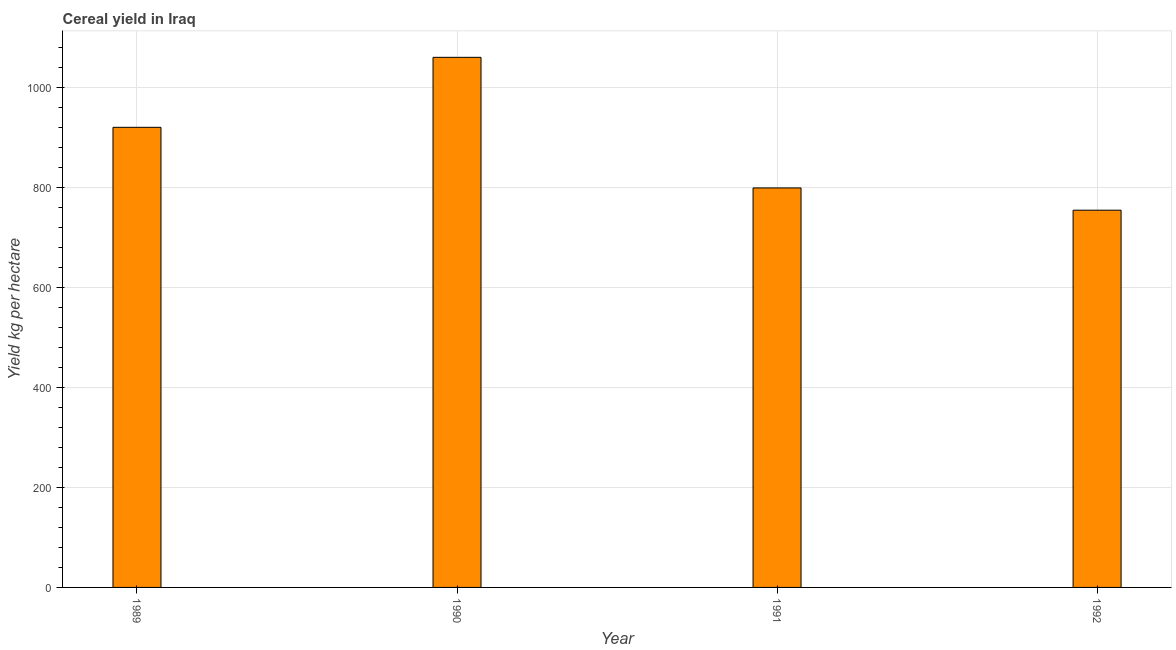Does the graph contain any zero values?
Your response must be concise. No. What is the title of the graph?
Ensure brevity in your answer.  Cereal yield in Iraq. What is the label or title of the X-axis?
Give a very brief answer. Year. What is the label or title of the Y-axis?
Make the answer very short. Yield kg per hectare. What is the cereal yield in 1992?
Keep it short and to the point. 755. Across all years, what is the maximum cereal yield?
Your response must be concise. 1060.96. Across all years, what is the minimum cereal yield?
Provide a succinct answer. 755. In which year was the cereal yield maximum?
Provide a short and direct response. 1990. What is the sum of the cereal yield?
Give a very brief answer. 3536.42. What is the difference between the cereal yield in 1990 and 1992?
Make the answer very short. 305.96. What is the average cereal yield per year?
Ensure brevity in your answer.  884.11. What is the median cereal yield?
Make the answer very short. 860.23. In how many years, is the cereal yield greater than 440 kg per hectare?
Offer a terse response. 4. What is the ratio of the cereal yield in 1991 to that in 1992?
Offer a very short reply. 1.06. Is the difference between the cereal yield in 1990 and 1992 greater than the difference between any two years?
Your answer should be compact. Yes. What is the difference between the highest and the second highest cereal yield?
Offer a terse response. 140.07. What is the difference between the highest and the lowest cereal yield?
Offer a very short reply. 305.96. In how many years, is the cereal yield greater than the average cereal yield taken over all years?
Offer a very short reply. 2. Are all the bars in the graph horizontal?
Your response must be concise. No. How many years are there in the graph?
Provide a short and direct response. 4. What is the difference between two consecutive major ticks on the Y-axis?
Ensure brevity in your answer.  200. What is the Yield kg per hectare in 1989?
Your answer should be compact. 920.89. What is the Yield kg per hectare in 1990?
Your response must be concise. 1060.96. What is the Yield kg per hectare in 1991?
Your response must be concise. 799.58. What is the Yield kg per hectare of 1992?
Offer a very short reply. 755. What is the difference between the Yield kg per hectare in 1989 and 1990?
Your answer should be compact. -140.07. What is the difference between the Yield kg per hectare in 1989 and 1991?
Provide a short and direct response. 121.31. What is the difference between the Yield kg per hectare in 1989 and 1992?
Give a very brief answer. 165.89. What is the difference between the Yield kg per hectare in 1990 and 1991?
Your answer should be very brief. 261.38. What is the difference between the Yield kg per hectare in 1990 and 1992?
Your answer should be compact. 305.96. What is the difference between the Yield kg per hectare in 1991 and 1992?
Your answer should be compact. 44.58. What is the ratio of the Yield kg per hectare in 1989 to that in 1990?
Make the answer very short. 0.87. What is the ratio of the Yield kg per hectare in 1989 to that in 1991?
Ensure brevity in your answer.  1.15. What is the ratio of the Yield kg per hectare in 1989 to that in 1992?
Your response must be concise. 1.22. What is the ratio of the Yield kg per hectare in 1990 to that in 1991?
Offer a very short reply. 1.33. What is the ratio of the Yield kg per hectare in 1990 to that in 1992?
Provide a short and direct response. 1.41. What is the ratio of the Yield kg per hectare in 1991 to that in 1992?
Make the answer very short. 1.06. 